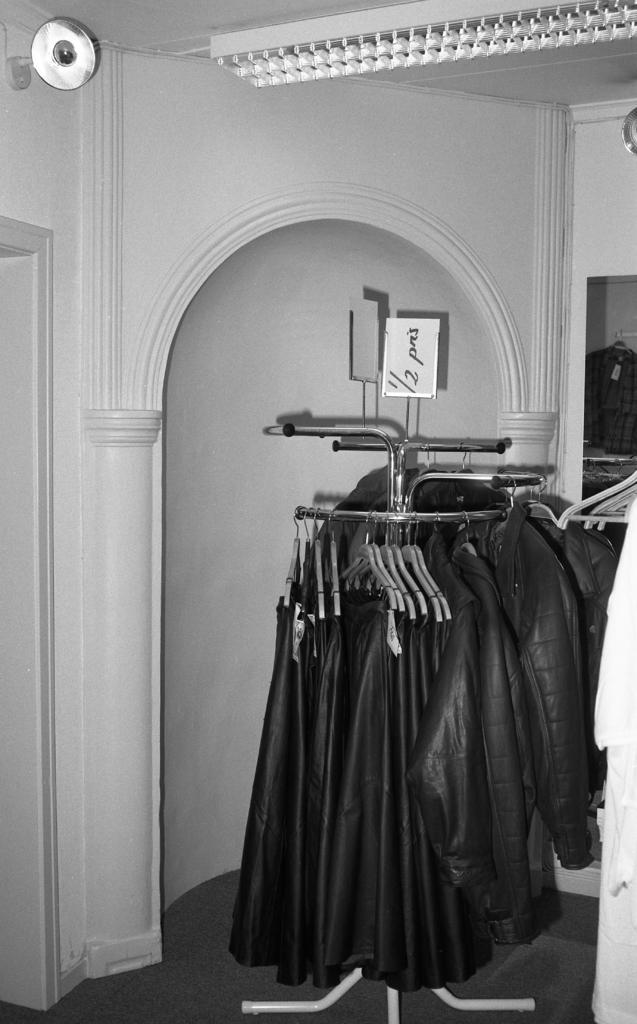What is the color scheme of the image? The image is black and white. What can be seen hanging on a stand in the image? Jackets are hanging on a stand in the image. What is visible in the background of the image? There is a door and lights in the background of the image. How many sources of light can be seen in the background? There are two sources of light in the background: a light on the wall and lights on the ceiling. Can you see any ants crawling on the jackets in the image? No, there are no ants visible in the image. What type of button is attached to the light on the wall in the image? There is no button present on the light in the image; it is simply a light fixture. 